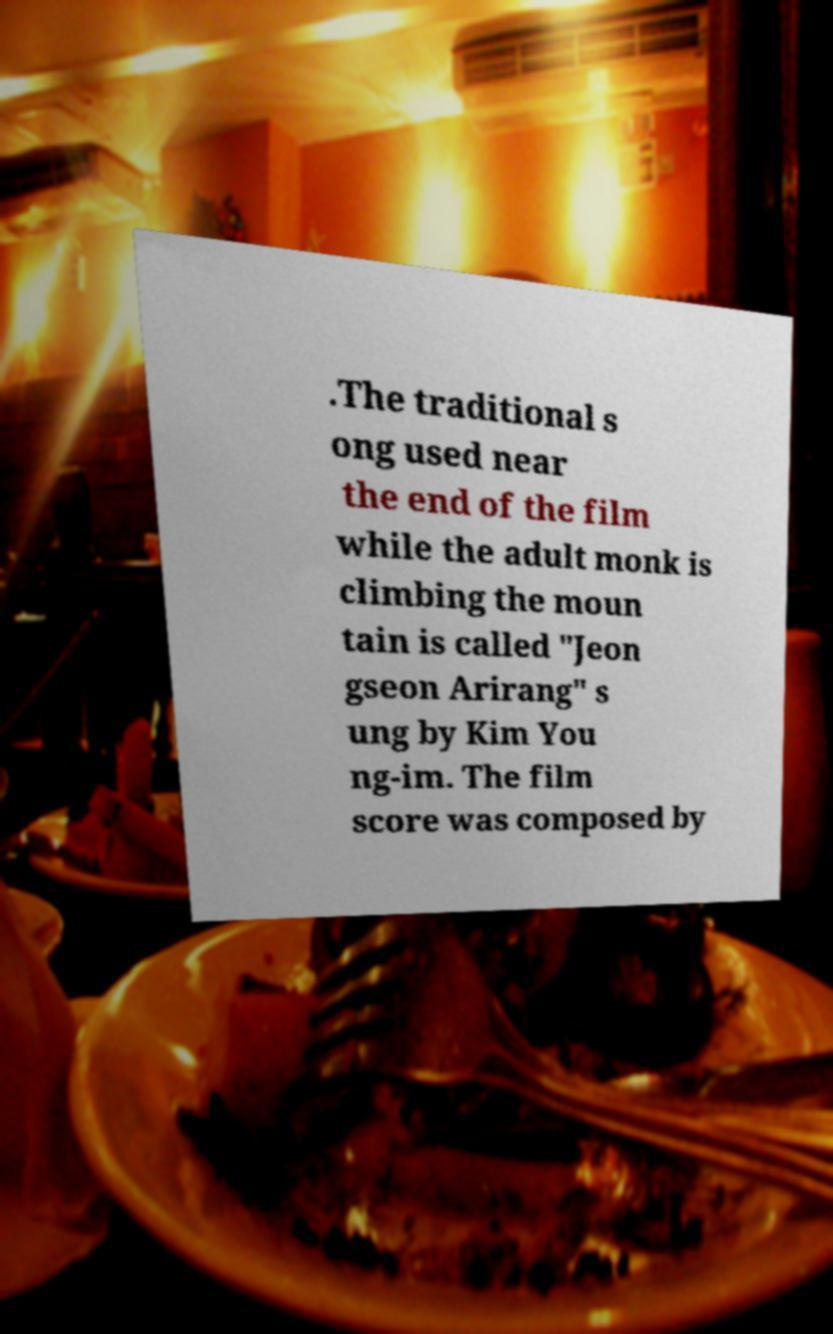Please read and relay the text visible in this image. What does it say? .The traditional s ong used near the end of the film while the adult monk is climbing the moun tain is called "Jeon gseon Arirang" s ung by Kim You ng-im. The film score was composed by 